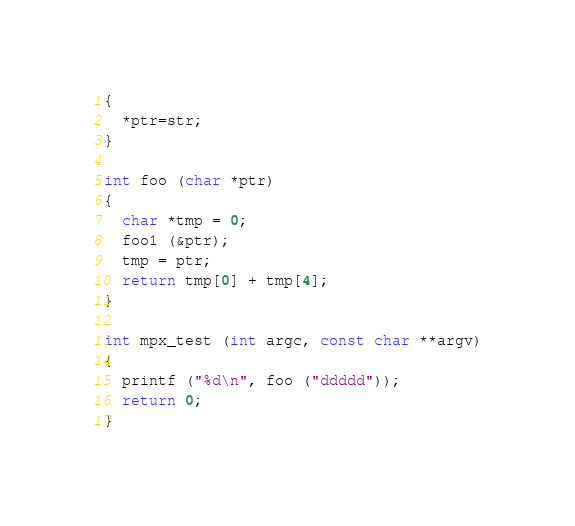Convert code to text. <code><loc_0><loc_0><loc_500><loc_500><_C_>{
  *ptr=str;
}

int foo (char *ptr)
{
  char *tmp = 0;
  foo1 (&ptr);
  tmp = ptr;
  return tmp[0] + tmp[4];
}

int mpx_test (int argc, const char **argv)
{
  printf ("%d\n", foo ("ddddd"));
  return 0;
}
</code> 